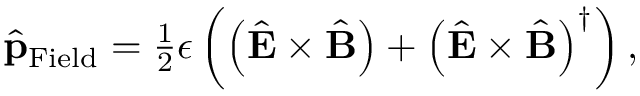<formula> <loc_0><loc_0><loc_500><loc_500>\begin{array} { r } { \hat { p } _ { F i e l d } = \frac { 1 } { 2 } \epsilon \left ( \left ( \hat { E } \times \hat { B } \right ) + \left ( \hat { E } \times \hat { B } \right ) ^ { \dagger } \right ) , } \end{array}</formula> 